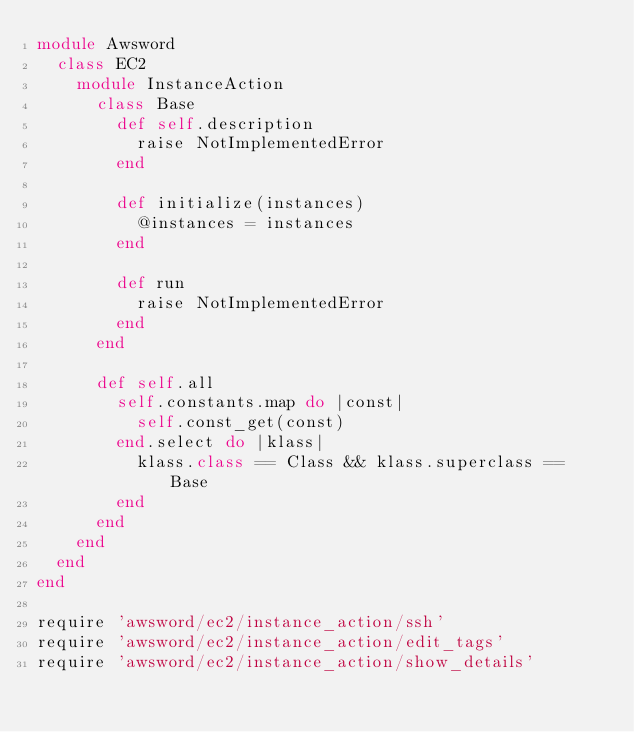<code> <loc_0><loc_0><loc_500><loc_500><_Ruby_>module Awsword
  class EC2
    module InstanceAction
      class Base
        def self.description
          raise NotImplementedError
        end

        def initialize(instances)
          @instances = instances
        end

        def run
          raise NotImplementedError
        end
      end

      def self.all
        self.constants.map do |const|
          self.const_get(const)
        end.select do |klass|
          klass.class == Class && klass.superclass == Base
        end
      end
    end
  end
end

require 'awsword/ec2/instance_action/ssh'
require 'awsword/ec2/instance_action/edit_tags'
require 'awsword/ec2/instance_action/show_details'

</code> 